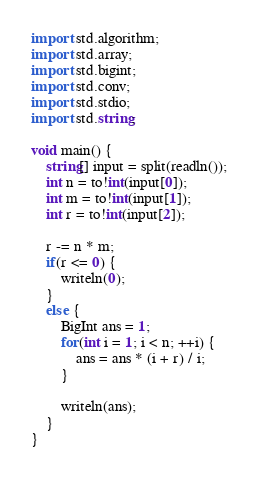Convert code to text. <code><loc_0><loc_0><loc_500><loc_500><_D_>import std.algorithm;
import std.array;
import std.bigint;
import std.conv;
import std.stdio;
import std.string;

void main() {
	string[] input = split(readln());
	int n = to!int(input[0]);
	int m = to!int(input[1]);
	int r = to!int(input[2]);

	r -= n * m;
	if(r <= 0) {
		writeln(0);
	}
	else {
		BigInt ans = 1;
		for(int i = 1; i < n; ++i) {
			ans = ans * (i + r) / i;
		}

		writeln(ans);
	}
}</code> 